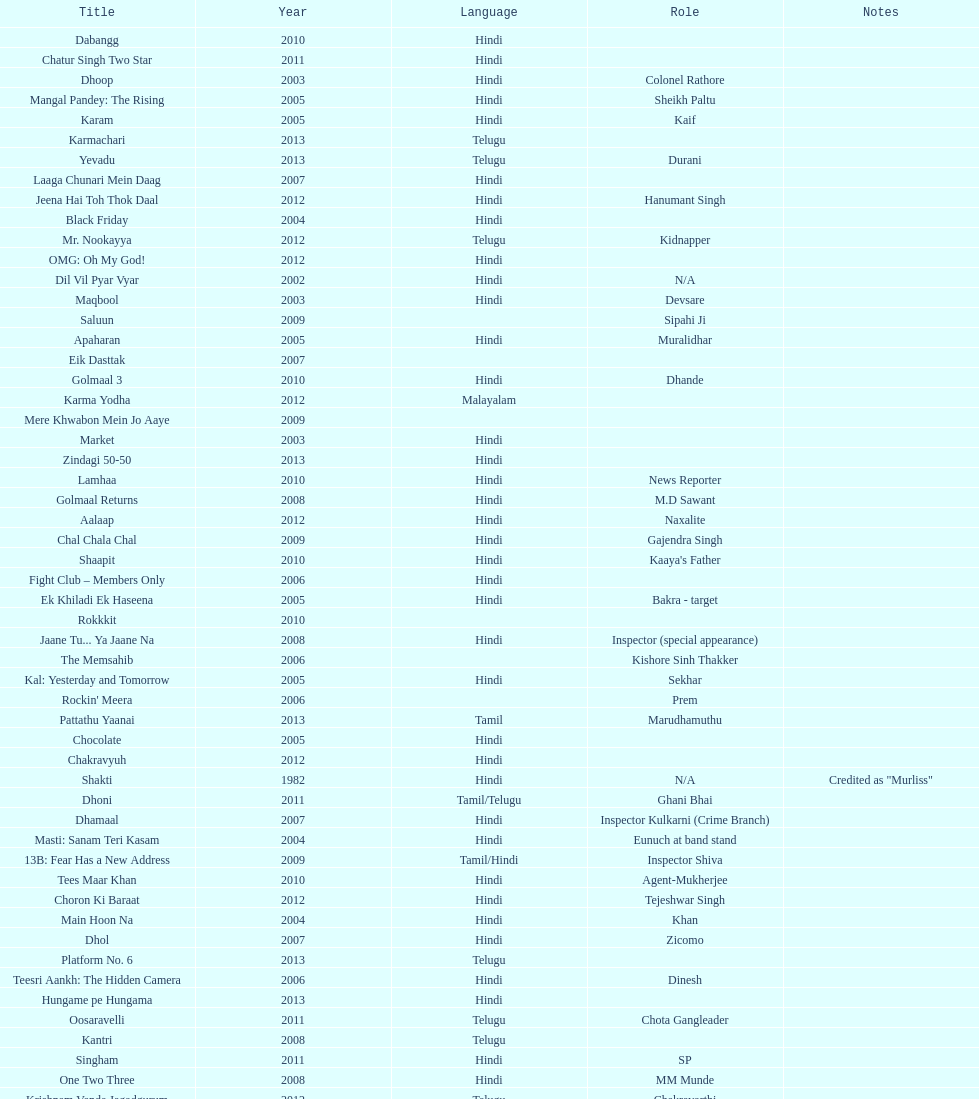What movie did this actor star in after they starred in dil vil pyar vyar in 2002? Maqbool. 